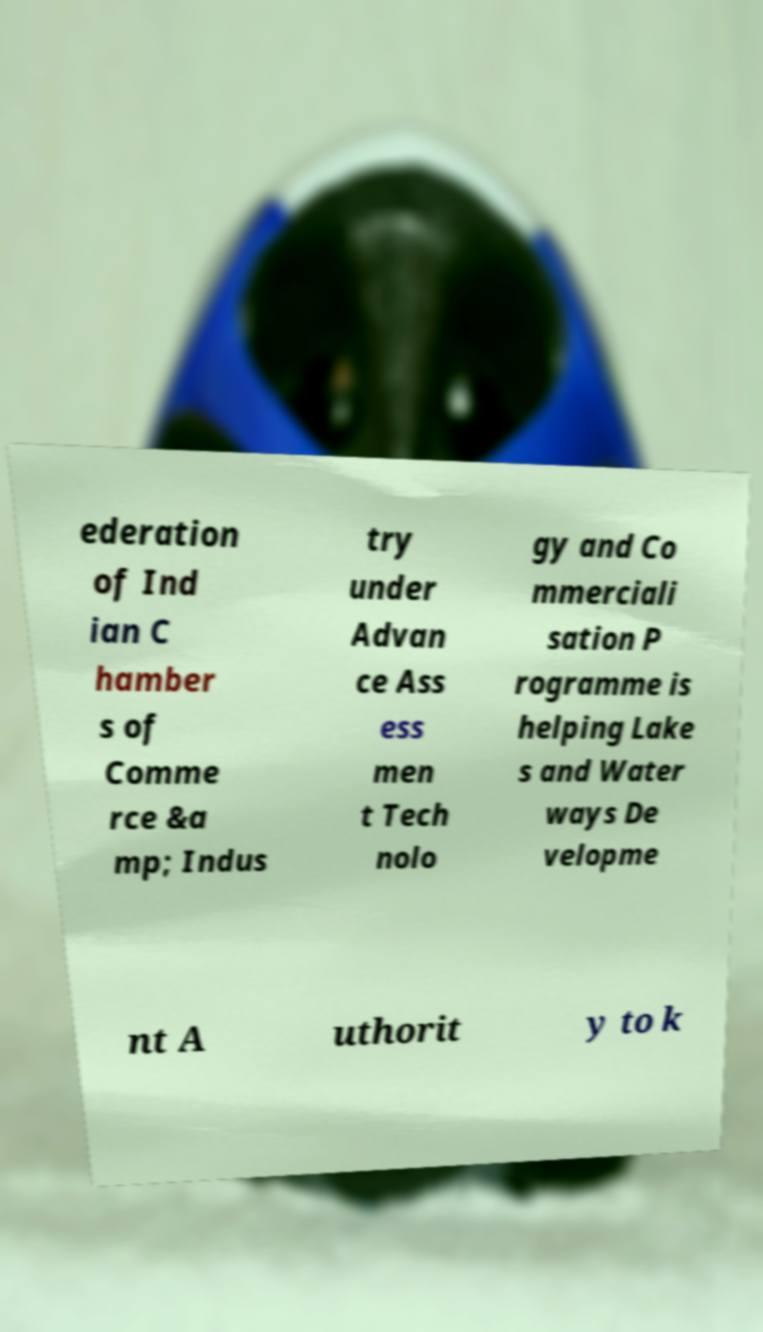I need the written content from this picture converted into text. Can you do that? ederation of Ind ian C hamber s of Comme rce &a mp; Indus try under Advan ce Ass ess men t Tech nolo gy and Co mmerciali sation P rogramme is helping Lake s and Water ways De velopme nt A uthorit y to k 